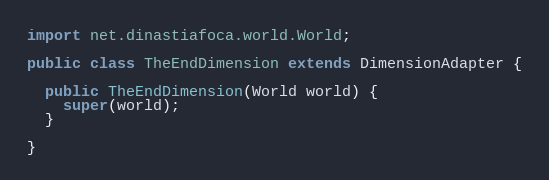<code> <loc_0><loc_0><loc_500><loc_500><_Java_>import net.dinastiafoca.world.World;

public class TheEndDimension extends DimensionAdapter {

  public TheEndDimension(World world) {
    super(world);
  }

}
</code> 